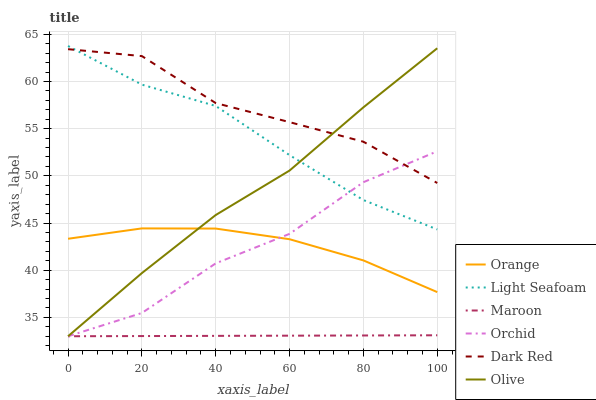Does Maroon have the minimum area under the curve?
Answer yes or no. Yes. Does Dark Red have the maximum area under the curve?
Answer yes or no. Yes. Does Olive have the minimum area under the curve?
Answer yes or no. No. Does Olive have the maximum area under the curve?
Answer yes or no. No. Is Maroon the smoothest?
Answer yes or no. Yes. Is Dark Red the roughest?
Answer yes or no. Yes. Is Olive the smoothest?
Answer yes or no. No. Is Olive the roughest?
Answer yes or no. No. Does Maroon have the lowest value?
Answer yes or no. Yes. Does Orange have the lowest value?
Answer yes or no. No. Does Light Seafoam have the highest value?
Answer yes or no. Yes. Does Olive have the highest value?
Answer yes or no. No. Is Maroon less than Orange?
Answer yes or no. Yes. Is Light Seafoam greater than Orange?
Answer yes or no. Yes. Does Olive intersect Light Seafoam?
Answer yes or no. Yes. Is Olive less than Light Seafoam?
Answer yes or no. No. Is Olive greater than Light Seafoam?
Answer yes or no. No. Does Maroon intersect Orange?
Answer yes or no. No. 